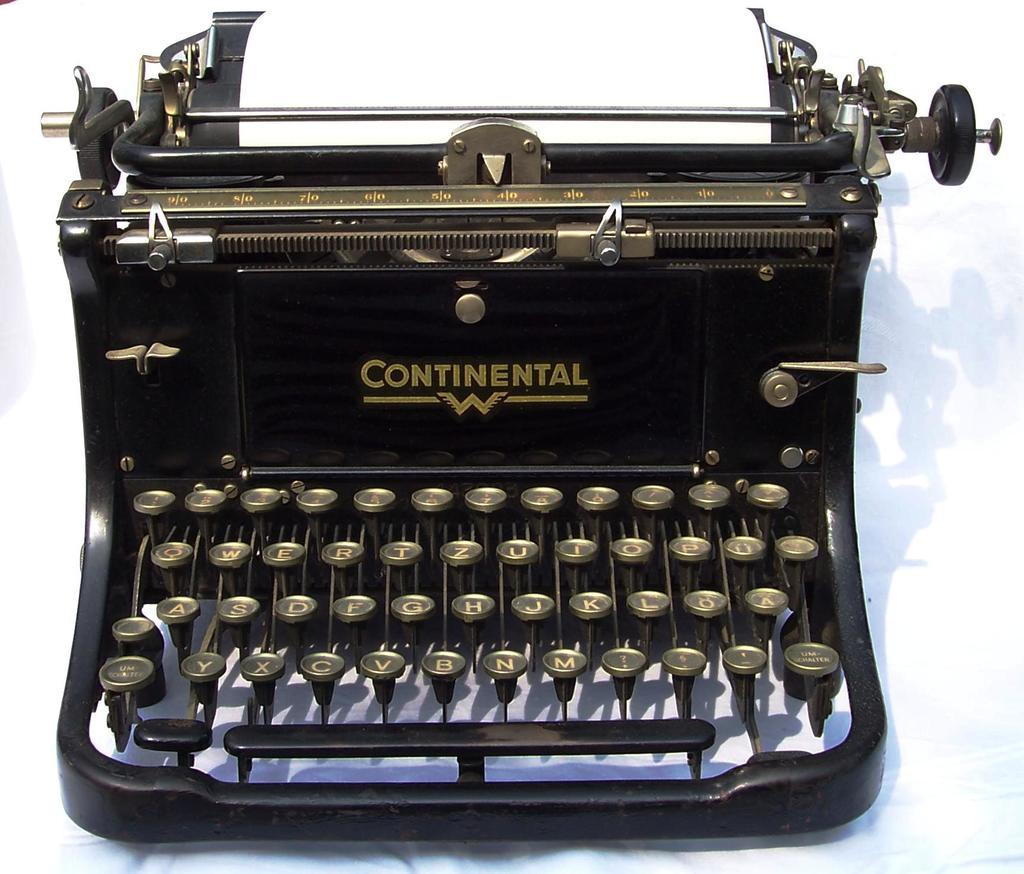What is the main object in the image? There is an old black typewriter in the image. What is written on the typewriter? The word "Continent" is written on the typewriter. What is the color of the background in the image? There is a white background in the image. How does the mother feel about the bean during the rainstorm in the image? There is no mother, bean, or rainstorm present in the image; it only features an old black typewriter with the word "Continent" written on it against a white background. 